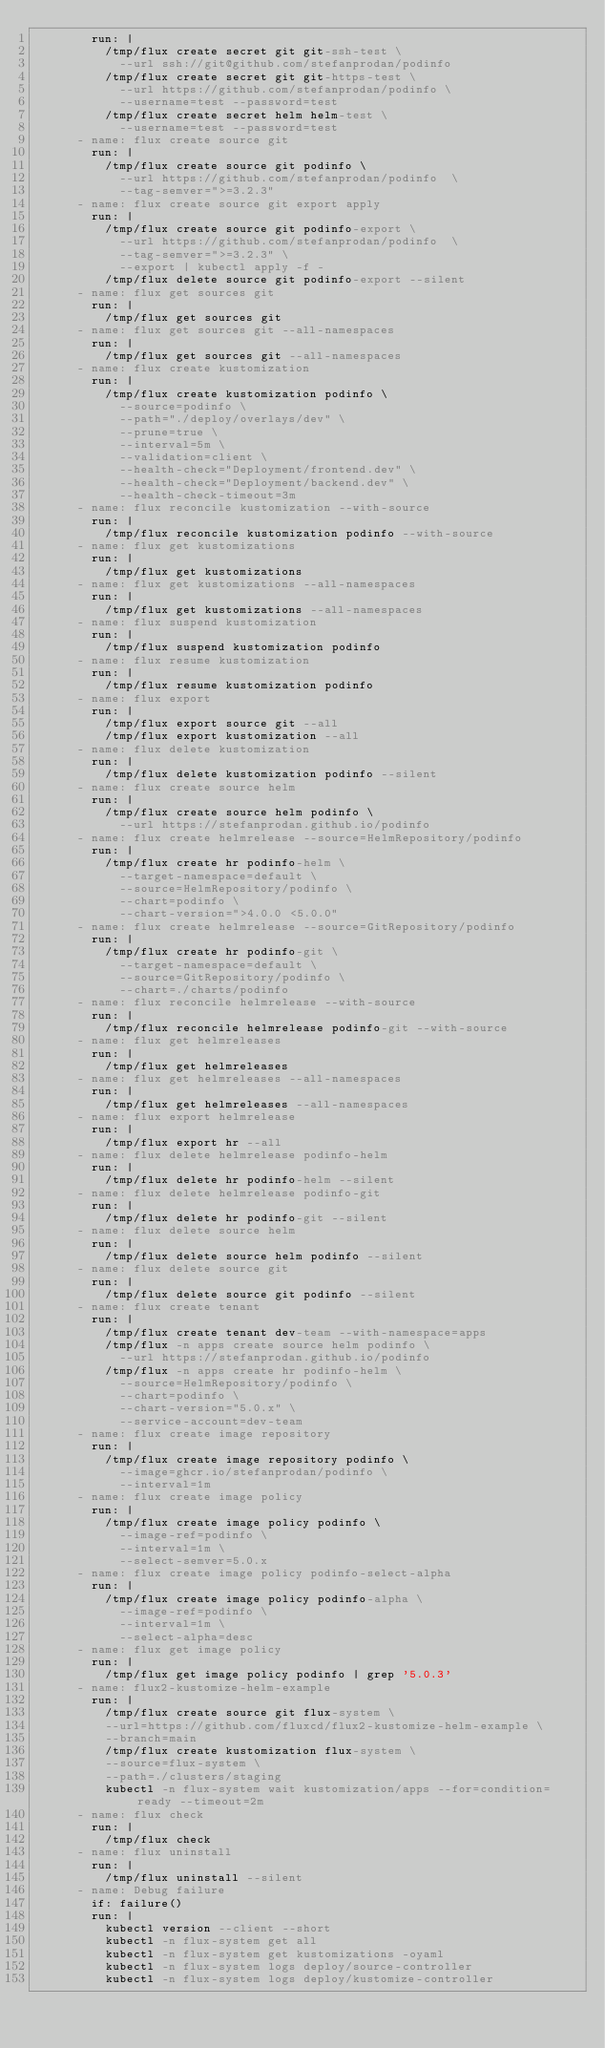Convert code to text. <code><loc_0><loc_0><loc_500><loc_500><_YAML_>        run: |
          /tmp/flux create secret git git-ssh-test \
            --url ssh://git@github.com/stefanprodan/podinfo
          /tmp/flux create secret git git-https-test \
            --url https://github.com/stefanprodan/podinfo \
            --username=test --password=test
          /tmp/flux create secret helm helm-test \
            --username=test --password=test
      - name: flux create source git
        run: |
          /tmp/flux create source git podinfo \
            --url https://github.com/stefanprodan/podinfo  \
            --tag-semver=">=3.2.3"
      - name: flux create source git export apply
        run: |
          /tmp/flux create source git podinfo-export \
            --url https://github.com/stefanprodan/podinfo  \
            --tag-semver=">=3.2.3" \
            --export | kubectl apply -f -
          /tmp/flux delete source git podinfo-export --silent
      - name: flux get sources git
        run: |
          /tmp/flux get sources git
      - name: flux get sources git --all-namespaces
        run: |
          /tmp/flux get sources git --all-namespaces
      - name: flux create kustomization
        run: |
          /tmp/flux create kustomization podinfo \
            --source=podinfo \
            --path="./deploy/overlays/dev" \
            --prune=true \
            --interval=5m \
            --validation=client \
            --health-check="Deployment/frontend.dev" \
            --health-check="Deployment/backend.dev" \
            --health-check-timeout=3m
      - name: flux reconcile kustomization --with-source
        run: |
          /tmp/flux reconcile kustomization podinfo --with-source
      - name: flux get kustomizations
        run: |
          /tmp/flux get kustomizations
      - name: flux get kustomizations --all-namespaces
        run: |
          /tmp/flux get kustomizations --all-namespaces
      - name: flux suspend kustomization
        run: |
          /tmp/flux suspend kustomization podinfo
      - name: flux resume kustomization
        run: |
          /tmp/flux resume kustomization podinfo
      - name: flux export
        run: |
          /tmp/flux export source git --all
          /tmp/flux export kustomization --all
      - name: flux delete kustomization
        run: |
          /tmp/flux delete kustomization podinfo --silent
      - name: flux create source helm
        run: |
          /tmp/flux create source helm podinfo \
            --url https://stefanprodan.github.io/podinfo
      - name: flux create helmrelease --source=HelmRepository/podinfo
        run: |
          /tmp/flux create hr podinfo-helm \
            --target-namespace=default \
            --source=HelmRepository/podinfo \
            --chart=podinfo \
            --chart-version=">4.0.0 <5.0.0"
      - name: flux create helmrelease --source=GitRepository/podinfo
        run: |
          /tmp/flux create hr podinfo-git \
            --target-namespace=default \
            --source=GitRepository/podinfo \
            --chart=./charts/podinfo
      - name: flux reconcile helmrelease --with-source
        run: |
          /tmp/flux reconcile helmrelease podinfo-git --with-source
      - name: flux get helmreleases
        run: |
          /tmp/flux get helmreleases
      - name: flux get helmreleases --all-namespaces
        run: |
          /tmp/flux get helmreleases --all-namespaces
      - name: flux export helmrelease
        run: |
          /tmp/flux export hr --all
      - name: flux delete helmrelease podinfo-helm
        run: |
          /tmp/flux delete hr podinfo-helm --silent
      - name: flux delete helmrelease podinfo-git
        run: |
          /tmp/flux delete hr podinfo-git --silent
      - name: flux delete source helm
        run: |
          /tmp/flux delete source helm podinfo --silent
      - name: flux delete source git
        run: |
          /tmp/flux delete source git podinfo --silent
      - name: flux create tenant
        run: |
          /tmp/flux create tenant dev-team --with-namespace=apps
          /tmp/flux -n apps create source helm podinfo \
            --url https://stefanprodan.github.io/podinfo
          /tmp/flux -n apps create hr podinfo-helm \
            --source=HelmRepository/podinfo \
            --chart=podinfo \
            --chart-version="5.0.x" \
            --service-account=dev-team
      - name: flux create image repository
        run: |
          /tmp/flux create image repository podinfo \
            --image=ghcr.io/stefanprodan/podinfo \
            --interval=1m
      - name: flux create image policy
        run: |
          /tmp/flux create image policy podinfo \
            --image-ref=podinfo \
            --interval=1m \
            --select-semver=5.0.x
      - name: flux create image policy podinfo-select-alpha
        run: |
          /tmp/flux create image policy podinfo-alpha \
            --image-ref=podinfo \
            --interval=1m \
            --select-alpha=desc
      - name: flux get image policy
        run: |
          /tmp/flux get image policy podinfo | grep '5.0.3'
      - name: flux2-kustomize-helm-example
        run: |
          /tmp/flux create source git flux-system \
          --url=https://github.com/fluxcd/flux2-kustomize-helm-example \
          --branch=main
          /tmp/flux create kustomization flux-system \
          --source=flux-system \
          --path=./clusters/staging
          kubectl -n flux-system wait kustomization/apps --for=condition=ready --timeout=2m
      - name: flux check
        run: |
          /tmp/flux check
      - name: flux uninstall
        run: |
          /tmp/flux uninstall --silent
      - name: Debug failure
        if: failure()
        run: |
          kubectl version --client --short
          kubectl -n flux-system get all
          kubectl -n flux-system get kustomizations -oyaml
          kubectl -n flux-system logs deploy/source-controller
          kubectl -n flux-system logs deploy/kustomize-controller
</code> 